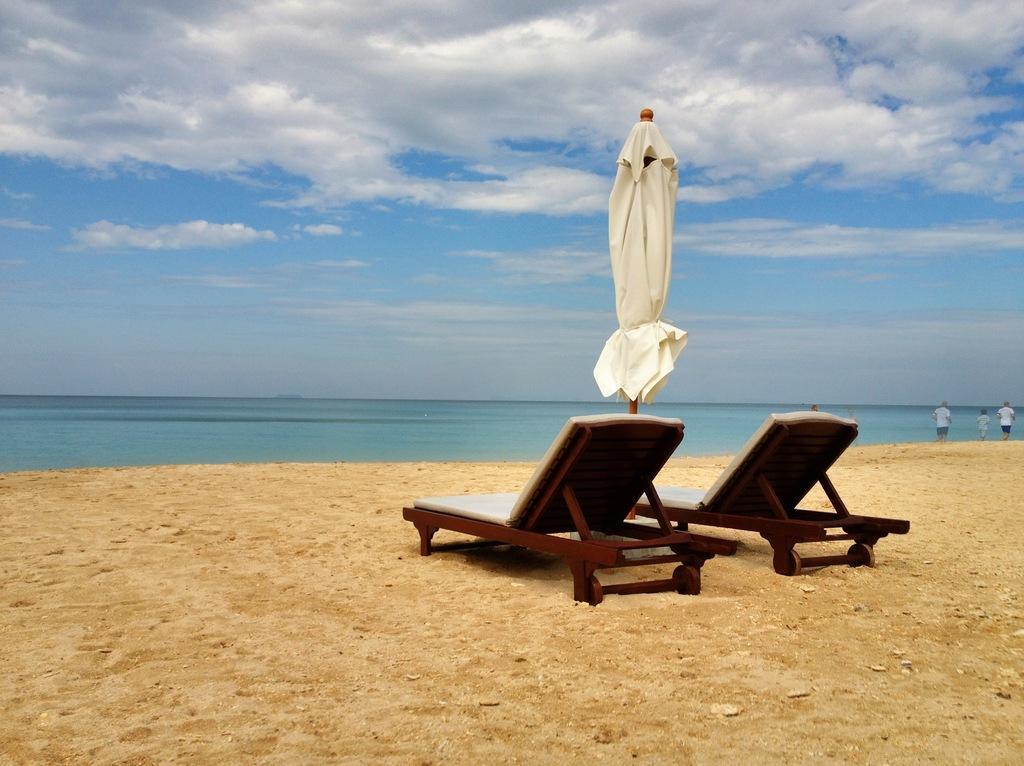In one or two sentences, can you explain what this image depicts? In this image there are two chairs on the land. In between the chairs there is an umbrella folded. Right side there are few persons walking on the land. Middle of image there is water. Top of image there is sky with some clouds. 